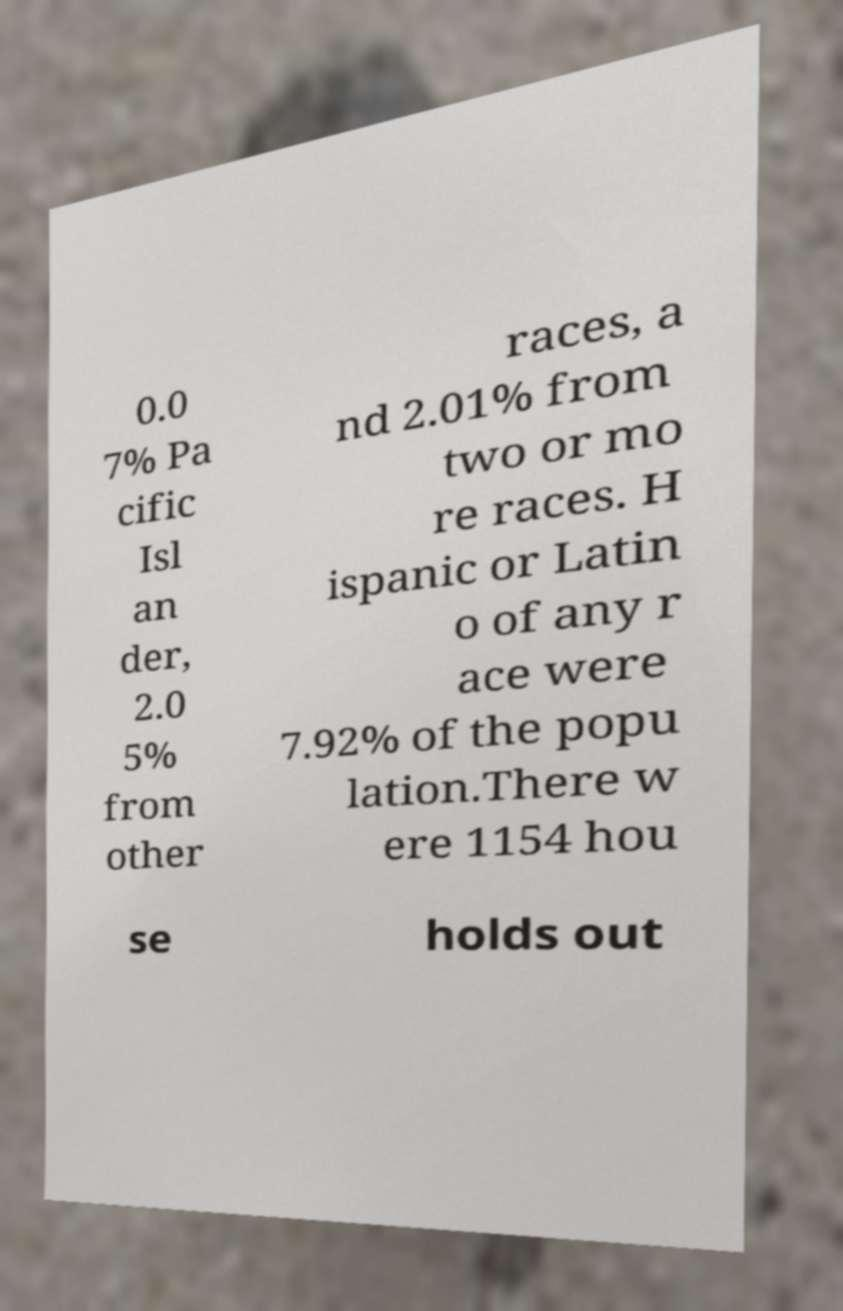Please read and relay the text visible in this image. What does it say? 0.0 7% Pa cific Isl an der, 2.0 5% from other races, a nd 2.01% from two or mo re races. H ispanic or Latin o of any r ace were 7.92% of the popu lation.There w ere 1154 hou se holds out 